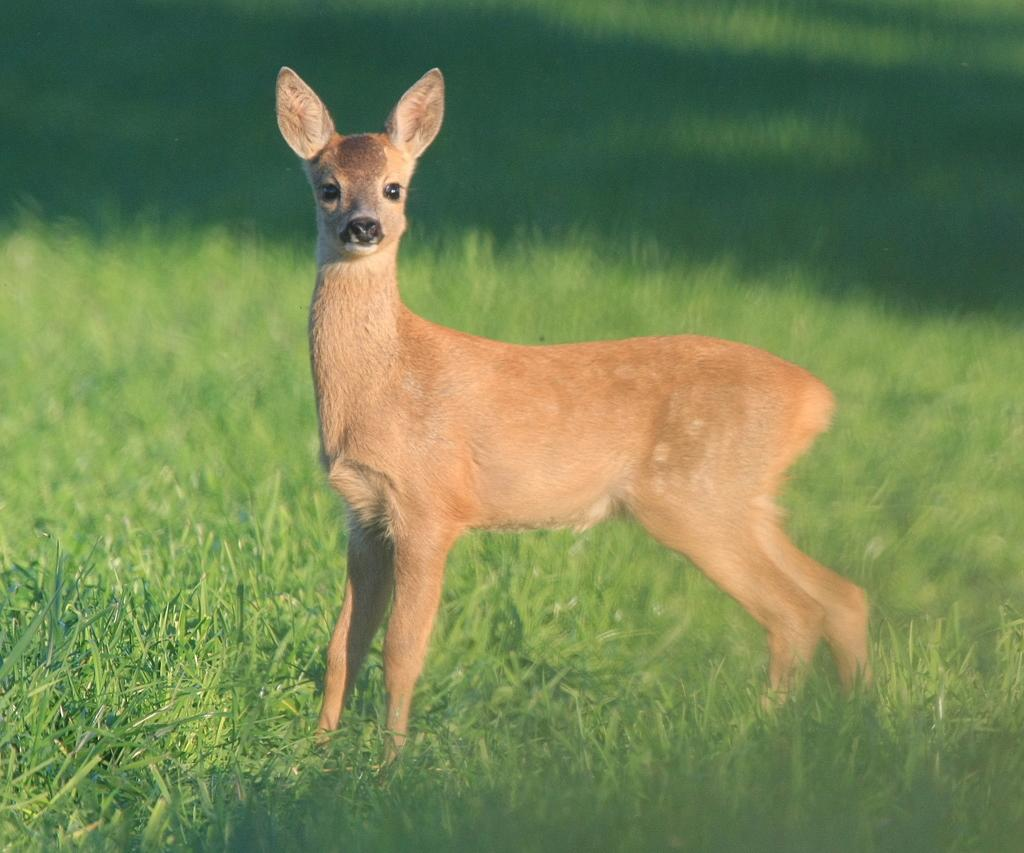What type of animal is present in the image? There is a deer in the image. What is the color of the deer in the image? The deer is in brown color. What type of vegetation is visible at the bottom of the image? There is green grass at the bottom of the image. How does the deer measure the height of the patch in the image? There is no patch present in the image, and therefore no such activity can be observed. 